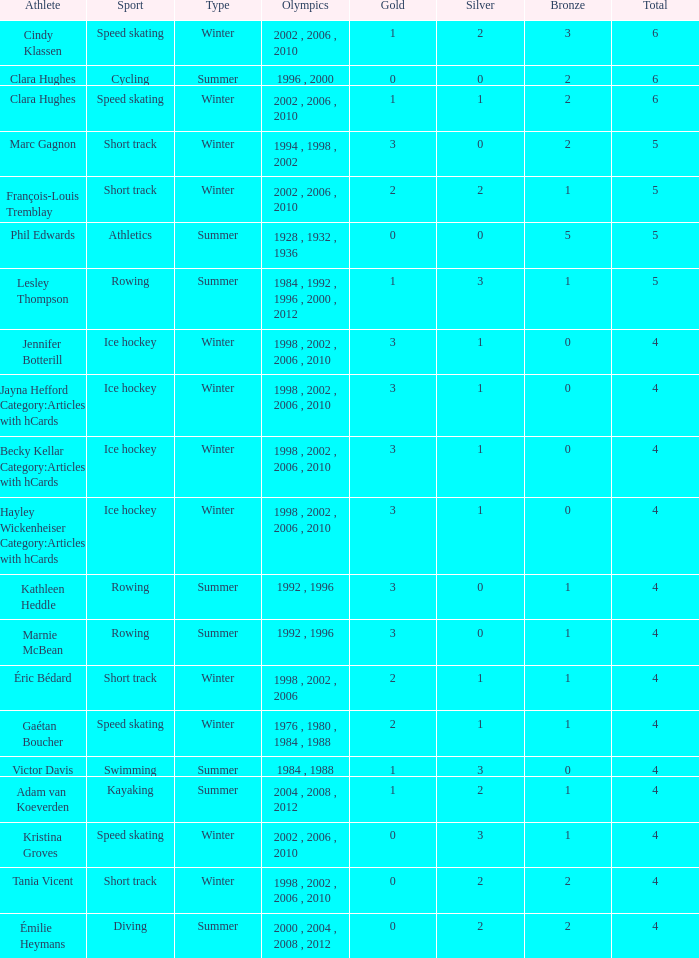What is the mean gold of the winter sportsman with 1 bronze, fewer than 3 silver, and fewer than 4 total medals? None. I'm looking to parse the entire table for insights. Could you assist me with that? {'header': ['Athlete', 'Sport', 'Type', 'Olympics', 'Gold', 'Silver', 'Bronze', 'Total'], 'rows': [['Cindy Klassen', 'Speed skating', 'Winter', '2002 , 2006 , 2010', '1', '2', '3', '6'], ['Clara Hughes', 'Cycling', 'Summer', '1996 , 2000', '0', '0', '2', '6'], ['Clara Hughes', 'Speed skating', 'Winter', '2002 , 2006 , 2010', '1', '1', '2', '6'], ['Marc Gagnon', 'Short track', 'Winter', '1994 , 1998 , 2002', '3', '0', '2', '5'], ['François-Louis Tremblay', 'Short track', 'Winter', '2002 , 2006 , 2010', '2', '2', '1', '5'], ['Phil Edwards', 'Athletics', 'Summer', '1928 , 1932 , 1936', '0', '0', '5', '5'], ['Lesley Thompson', 'Rowing', 'Summer', '1984 , 1992 , 1996 , 2000 , 2012', '1', '3', '1', '5'], ['Jennifer Botterill', 'Ice hockey', 'Winter', '1998 , 2002 , 2006 , 2010', '3', '1', '0', '4'], ['Jayna Hefford Category:Articles with hCards', 'Ice hockey', 'Winter', '1998 , 2002 , 2006 , 2010', '3', '1', '0', '4'], ['Becky Kellar Category:Articles with hCards', 'Ice hockey', 'Winter', '1998 , 2002 , 2006 , 2010', '3', '1', '0', '4'], ['Hayley Wickenheiser Category:Articles with hCards', 'Ice hockey', 'Winter', '1998 , 2002 , 2006 , 2010', '3', '1', '0', '4'], ['Kathleen Heddle', 'Rowing', 'Summer', '1992 , 1996', '3', '0', '1', '4'], ['Marnie McBean', 'Rowing', 'Summer', '1992 , 1996', '3', '0', '1', '4'], ['Éric Bédard', 'Short track', 'Winter', '1998 , 2002 , 2006', '2', '1', '1', '4'], ['Gaétan Boucher', 'Speed skating', 'Winter', '1976 , 1980 , 1984 , 1988', '2', '1', '1', '4'], ['Victor Davis', 'Swimming', 'Summer', '1984 , 1988', '1', '3', '0', '4'], ['Adam van Koeverden', 'Kayaking', 'Summer', '2004 , 2008 , 2012', '1', '2', '1', '4'], ['Kristina Groves', 'Speed skating', 'Winter', '2002 , 2006 , 2010', '0', '3', '1', '4'], ['Tania Vicent', 'Short track', 'Winter', '1998 , 2002 , 2006 , 2010', '0', '2', '2', '4'], ['Émilie Heymans', 'Diving', 'Summer', '2000 , 2004 , 2008 , 2012', '0', '2', '2', '4']]} 